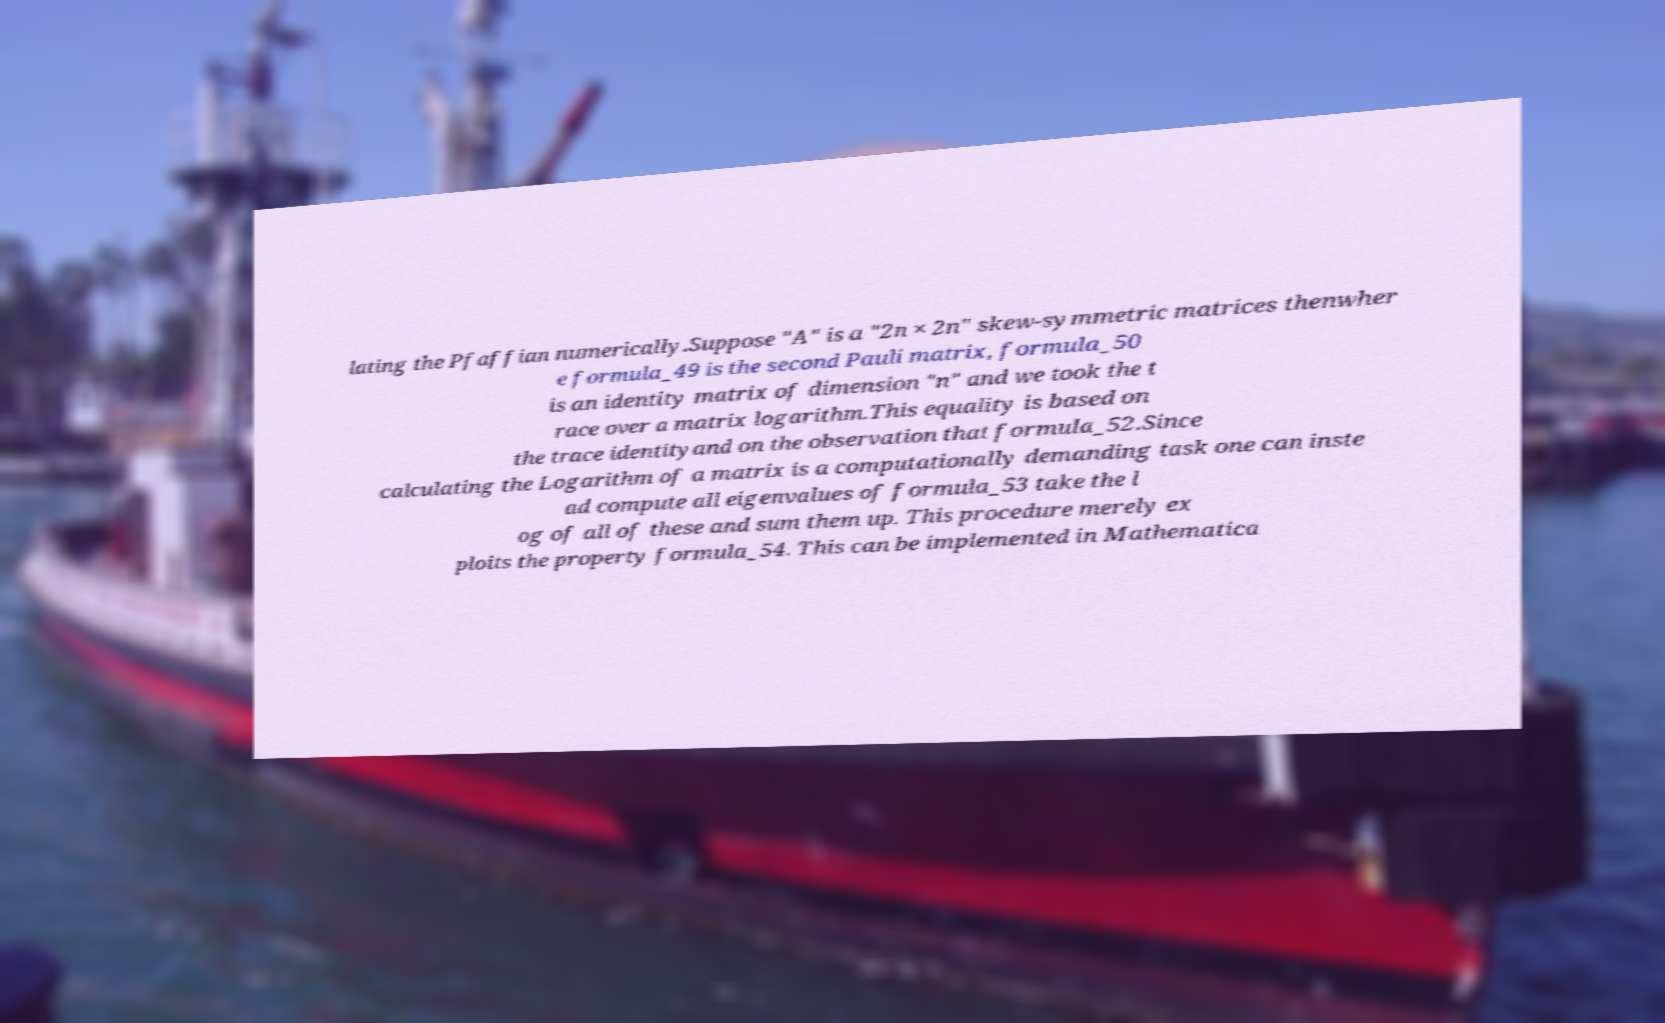I need the written content from this picture converted into text. Can you do that? lating the Pfaffian numerically.Suppose "A" is a "2n × 2n" skew-symmetric matrices thenwher e formula_49 is the second Pauli matrix, formula_50 is an identity matrix of dimension "n" and we took the t race over a matrix logarithm.This equality is based on the trace identityand on the observation that formula_52.Since calculating the Logarithm of a matrix is a computationally demanding task one can inste ad compute all eigenvalues of formula_53 take the l og of all of these and sum them up. This procedure merely ex ploits the property formula_54. This can be implemented in Mathematica 